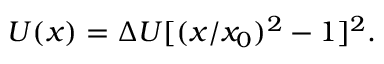Convert formula to latex. <formula><loc_0><loc_0><loc_500><loc_500>U ( x ) = \Delta U [ ( x / x _ { 0 } ) ^ { 2 } - 1 ] ^ { 2 } .</formula> 